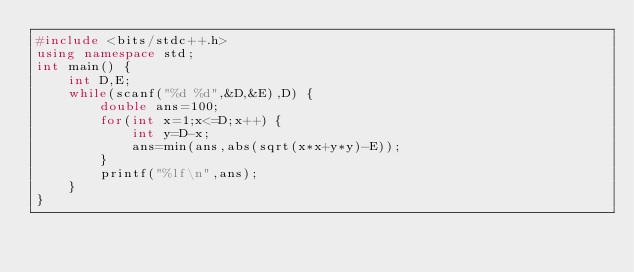Convert code to text. <code><loc_0><loc_0><loc_500><loc_500><_C++_>#include <bits/stdc++.h>
using namespace std;
int main() {
    int D,E;
    while(scanf("%d %d",&D,&E),D) {
        double ans=100;
        for(int x=1;x<=D;x++) {
            int y=D-x;
            ans=min(ans,abs(sqrt(x*x+y*y)-E));
        }
        printf("%lf\n",ans);
    }
}</code> 